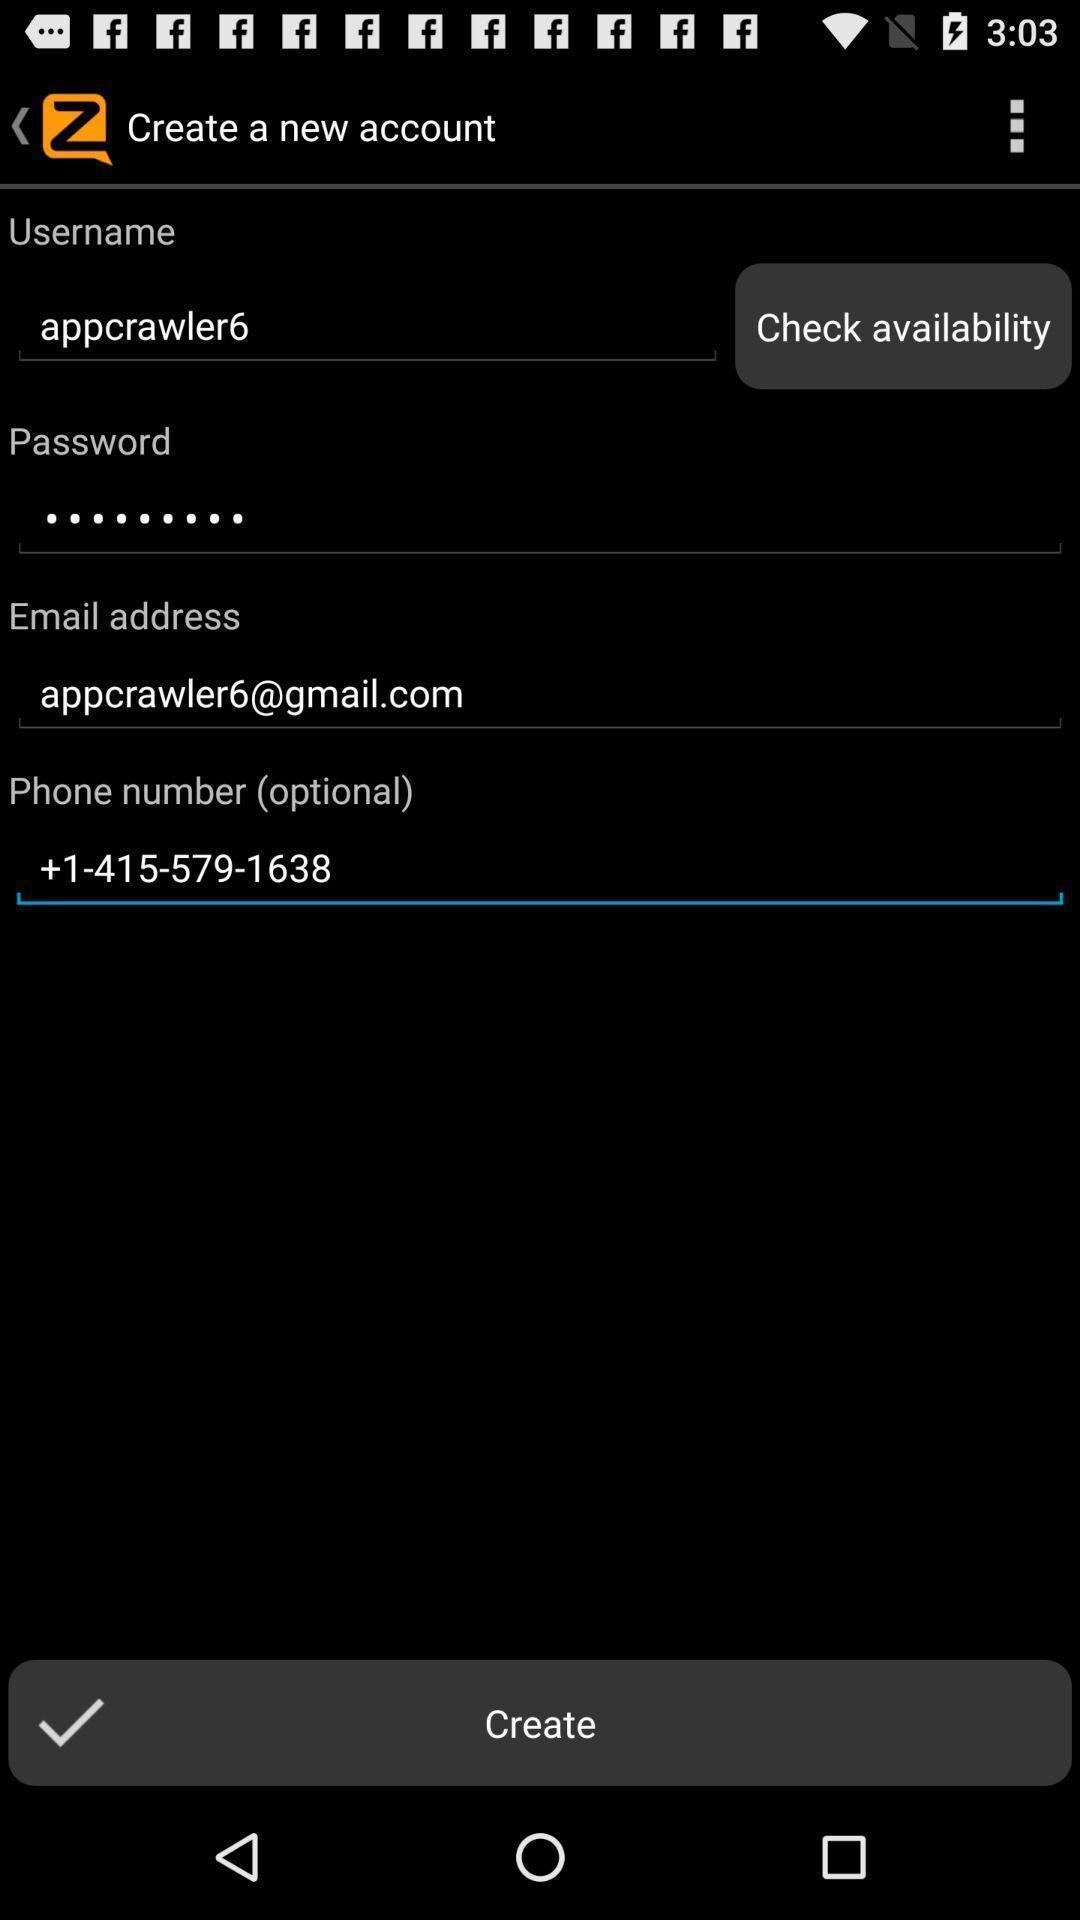Provide a textual representation of this image. Page for creating an account. 